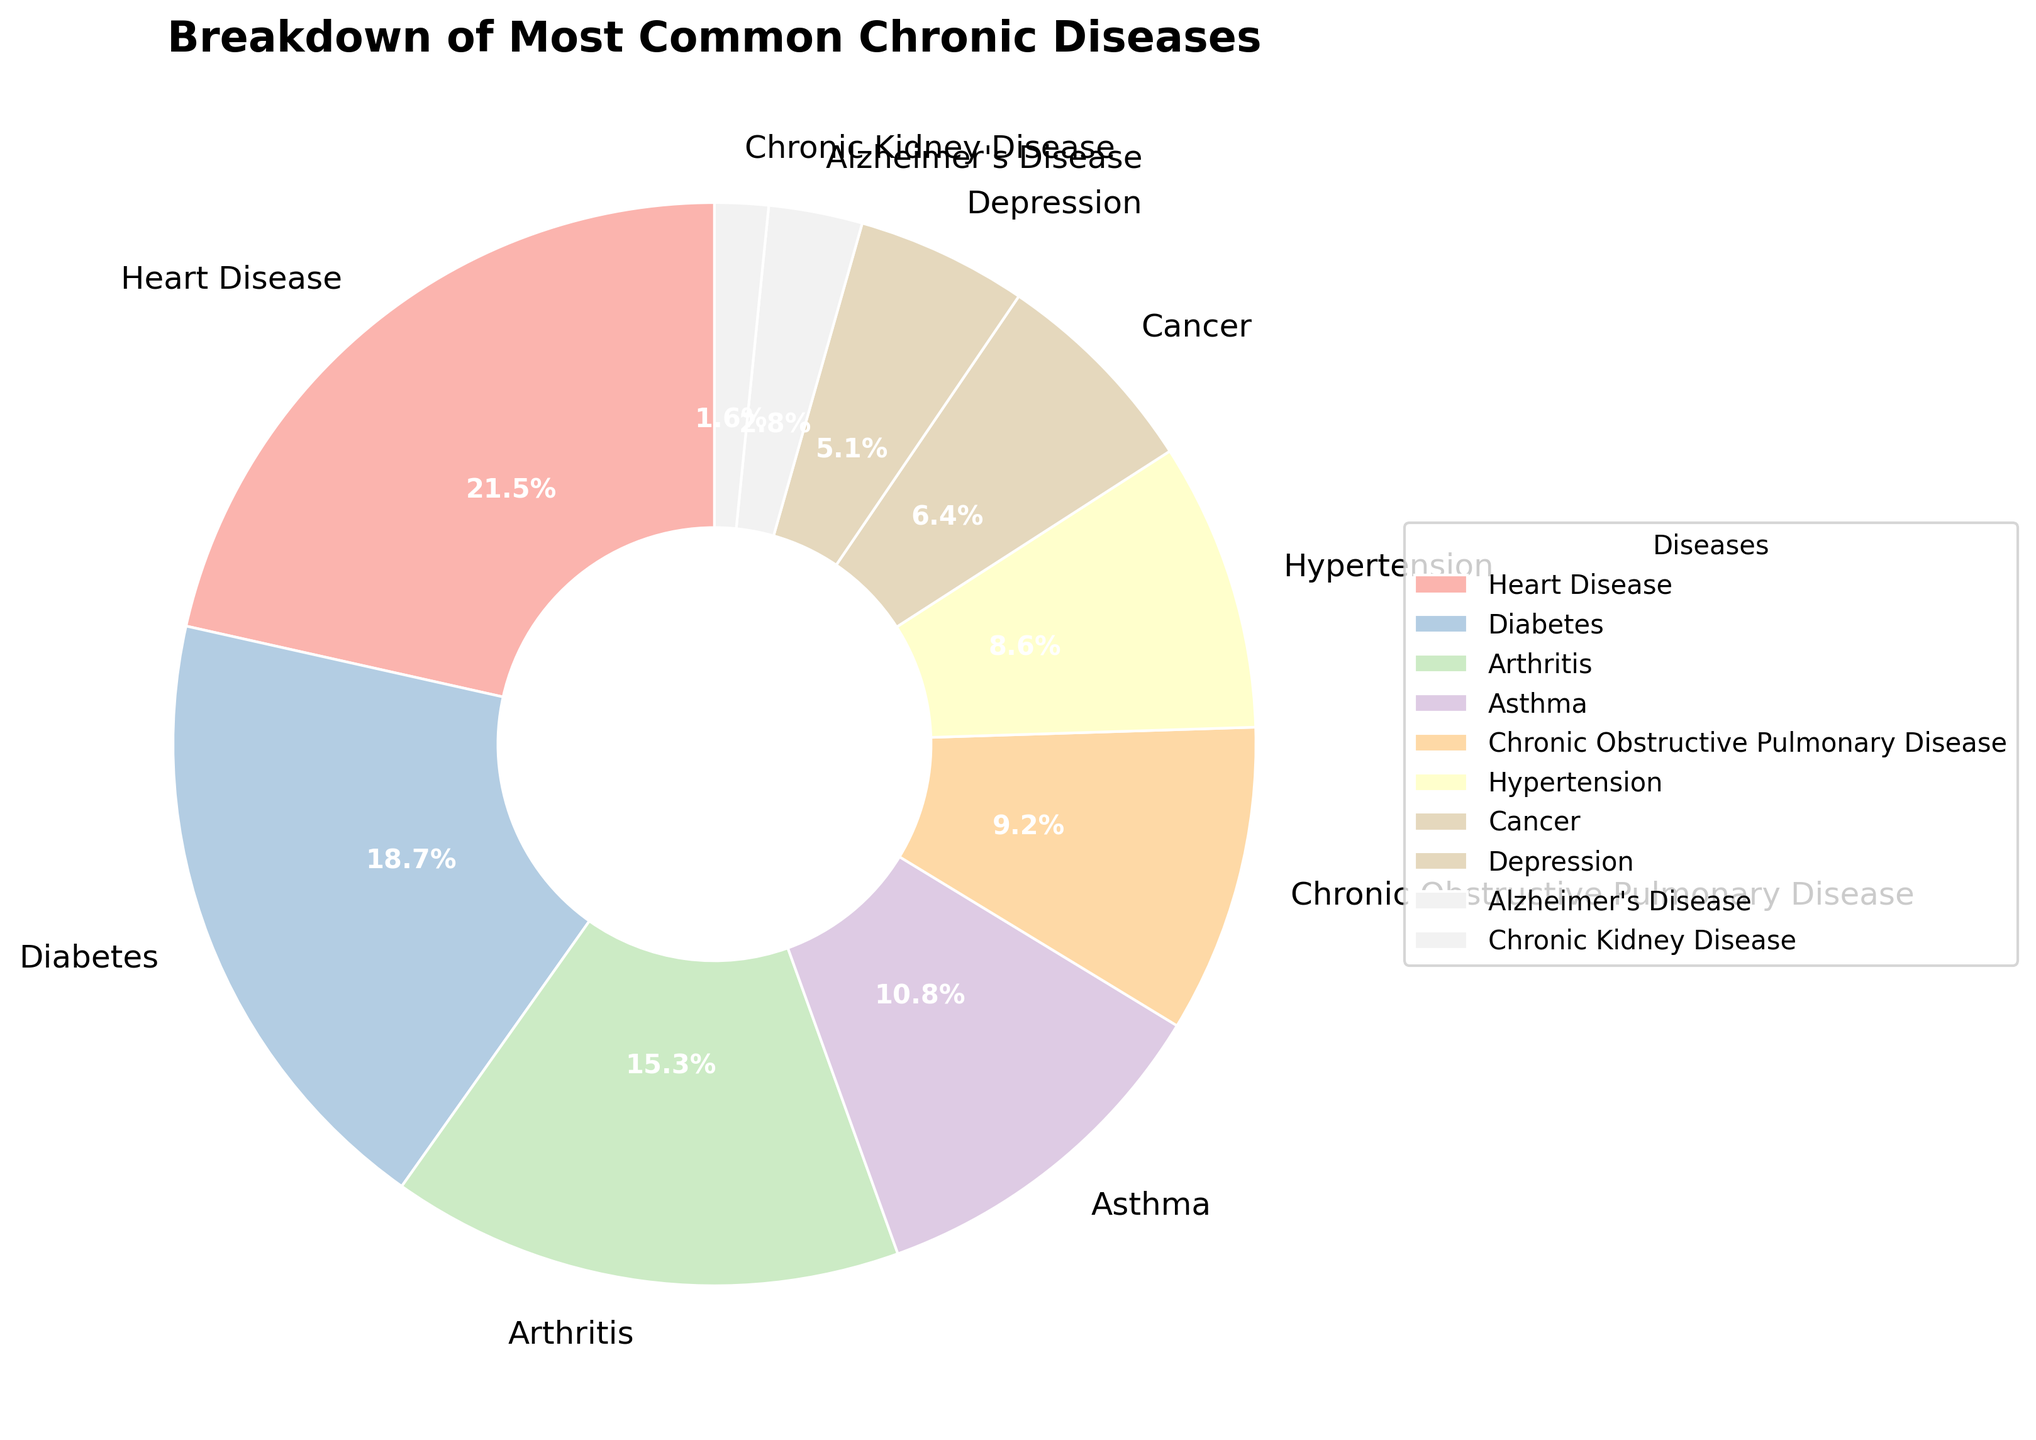What is the most common chronic disease affecting the state's population? Heart Disease takes up the largest portion of the pie chart at 21.5%.
Answer: Heart Disease Which disease has a slightly lower percentage than Diabetes? Arthritis has a slightly lower percentage than Diabetes, with Diabetes at 18.7% and Arthritis at 15.3%.
Answer: Arthritis Which two diseases combined have a percentage higher than 25% but less than 40%? Diabetes and Arthritis combined have a percentage of 18.7% + 15.3% = 34%, which is between 25% and 40%.
Answer: Diabetes and Arthritis How much larger is the percentage of Heart Disease than Hypertension? Heart Disease has a percentage of 21.5%, and Hypertension has 8.6%. The difference is 21.5% - 8.6% = 12.9%.
Answer: 12.9% What is the smallest portion on the pie chart? Chronic Kidney Disease is the smallest portion on the pie chart at 1.6%.
Answer: Chronic Kidney Disease What percentage of the population is affected by either Cancer or Depression? Cancer affects 6.4% and Depression affects 5.1%. Combined, they affect 6.4% + 5.1% = 11.5% of the population.
Answer: 11.5% Compare the prevalence of Asthma and Chronic Obstructive Pulmonary Disease (COPD). Asthma affects 10.8% of the population, while COPD affects 9.2%. Asthma affects a higher percentage of the population than COPD.
Answer: Asthma Which diseases have percentages lower than 10%? The diseases with percentages lower than 10% are Chronic Obstructive Pulmonary Disease (9.2%), Hypertension (8.6%), Cancer (6.4%), Depression (5.1%), Alzheimer’s Disease (2.8%), and Chronic Kidney Disease (1.6%).
Answer: Chronic Obstructive Pulmonary Disease, Hypertension, Cancer, Depression, Alzheimer’s Disease, and Chronic Kidney Disease How much greater is the combined percentage of Heart Disease and Diabetes compared to Asthma? Heart Disease and Diabetes together account for 21.5% + 18.7% = 40.2%. Asthma accounts for 10.8%. The difference is 40.2% - 10.8% = 29.4%.
Answer: 29.4% Which disease has the closest percentage to 5%? Depression has a percentage closest to 5% at 5.1%.
Answer: Depression 